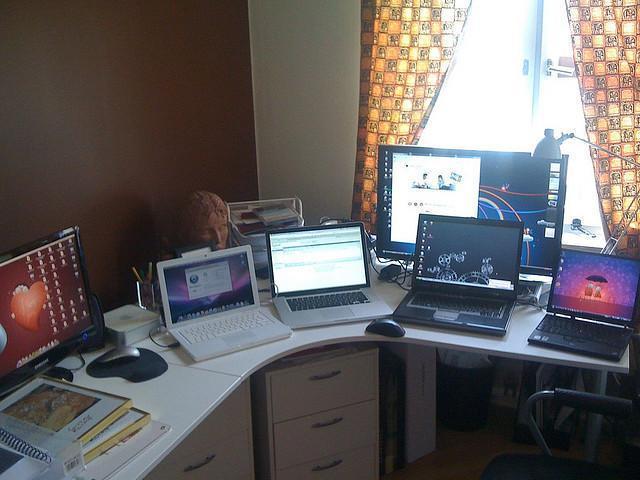How many computers?
Give a very brief answer. 6. How many are laptops?
Give a very brief answer. 4. How many books are there?
Give a very brief answer. 1. How many tvs are there?
Give a very brief answer. 2. How many laptops are there?
Give a very brief answer. 4. How many keyboards can be seen?
Give a very brief answer. 3. 